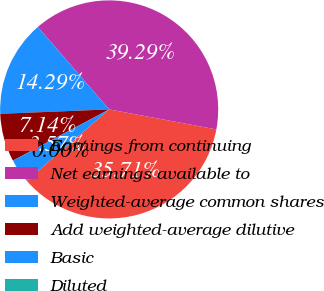Convert chart. <chart><loc_0><loc_0><loc_500><loc_500><pie_chart><fcel>Earnings from continuing<fcel>Net earnings available to<fcel>Weighted-average common shares<fcel>Add weighted-average dilutive<fcel>Basic<fcel>Diluted<nl><fcel>35.71%<fcel>39.29%<fcel>14.29%<fcel>7.14%<fcel>3.57%<fcel>0.0%<nl></chart> 